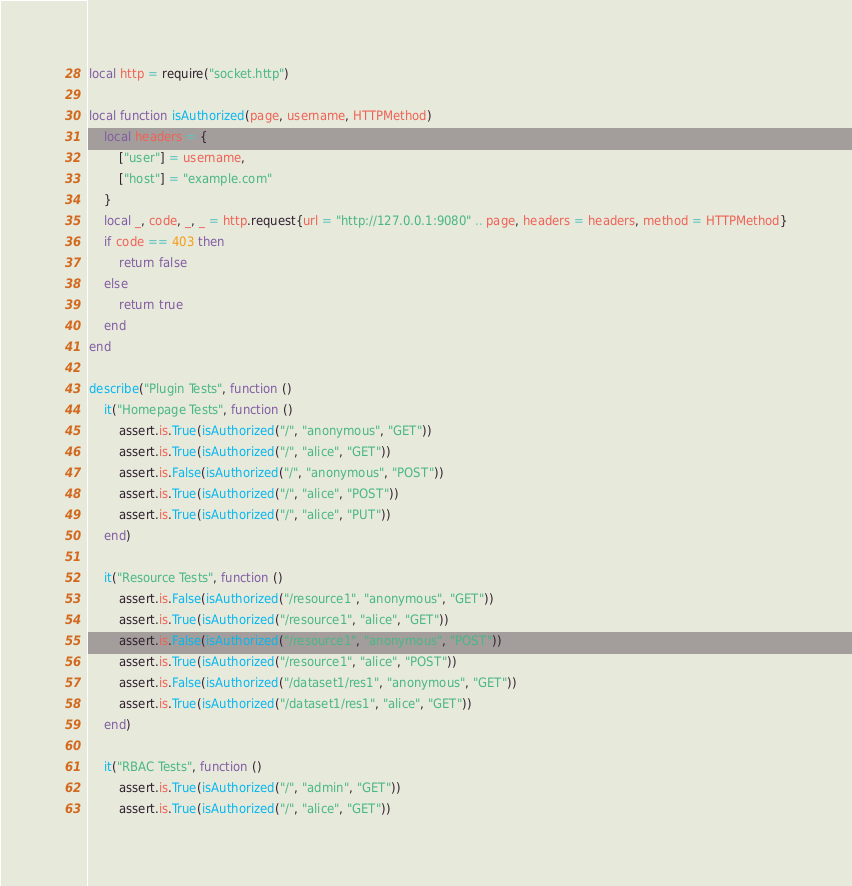Convert code to text. <code><loc_0><loc_0><loc_500><loc_500><_Lua_>local http = require("socket.http")

local function isAuthorized(page, username, HTTPMethod)
    local headers = {
        ["user"] = username,
        ["host"] = "example.com"
    }
    local _, code, _, _ = http.request{url = "http://127.0.0.1:9080" .. page, headers = headers, method = HTTPMethod}
    if code == 403 then
        return false
    else
        return true
    end
end

describe("Plugin Tests", function ()
    it("Homepage Tests", function ()
        assert.is.True(isAuthorized("/", "anonymous", "GET"))
        assert.is.True(isAuthorized("/", "alice", "GET"))
        assert.is.False(isAuthorized("/", "anonymous", "POST"))
        assert.is.True(isAuthorized("/", "alice", "POST"))
        assert.is.True(isAuthorized("/", "alice", "PUT"))
    end)

    it("Resource Tests", function ()
        assert.is.False(isAuthorized("/resource1", "anonymous", "GET"))
        assert.is.True(isAuthorized("/resource1", "alice", "GET"))
        assert.is.False(isAuthorized("/resource1", "anonymous", "POST"))
        assert.is.True(isAuthorized("/resource1", "alice", "POST"))
        assert.is.False(isAuthorized("/dataset1/res1", "anonymous", "GET"))
        assert.is.True(isAuthorized("/dataset1/res1", "alice", "GET"))
    end)

    it("RBAC Tests", function ()
        assert.is.True(isAuthorized("/", "admin", "GET"))
        assert.is.True(isAuthorized("/", "alice", "GET"))</code> 